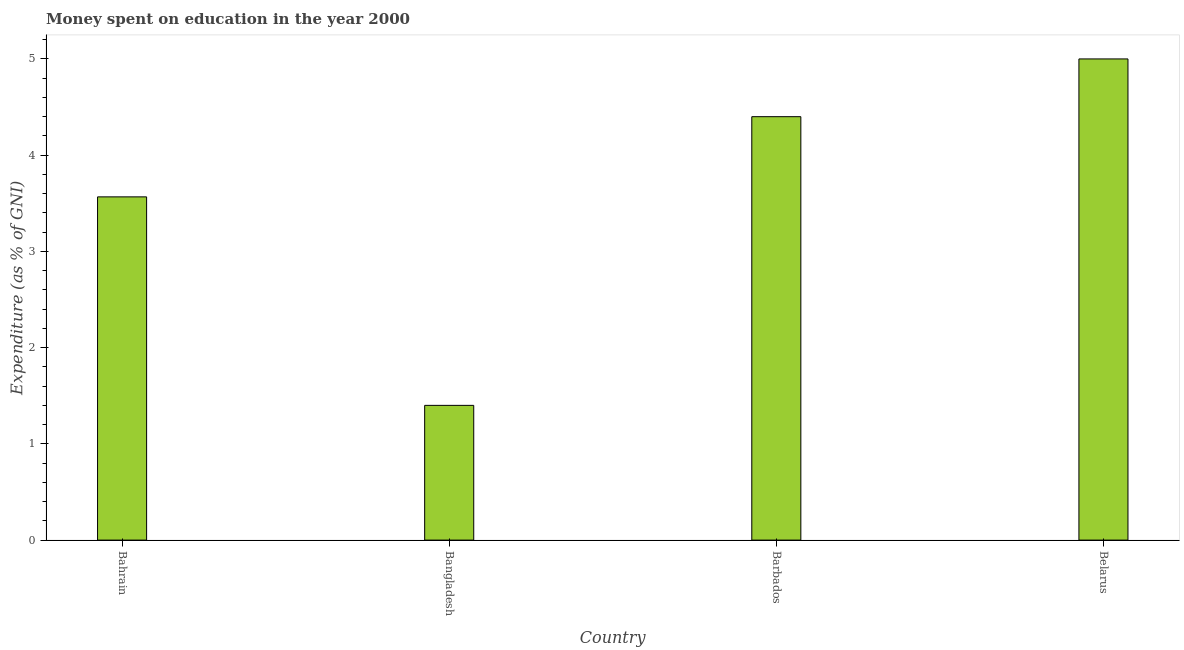Does the graph contain any zero values?
Provide a short and direct response. No. Does the graph contain grids?
Your answer should be very brief. No. What is the title of the graph?
Your answer should be compact. Money spent on education in the year 2000. What is the label or title of the X-axis?
Ensure brevity in your answer.  Country. What is the label or title of the Y-axis?
Your response must be concise. Expenditure (as % of GNI). What is the expenditure on education in Bangladesh?
Make the answer very short. 1.4. In which country was the expenditure on education maximum?
Make the answer very short. Belarus. What is the sum of the expenditure on education?
Your answer should be very brief. 14.37. What is the difference between the expenditure on education in Bahrain and Barbados?
Keep it short and to the point. -0.83. What is the average expenditure on education per country?
Your answer should be compact. 3.59. What is the median expenditure on education?
Your answer should be very brief. 3.98. In how many countries, is the expenditure on education greater than 4.4 %?
Your response must be concise. 1. What is the ratio of the expenditure on education in Bahrain to that in Bangladesh?
Your answer should be very brief. 2.55. Is the expenditure on education in Barbados less than that in Belarus?
Offer a terse response. Yes. How many bars are there?
Keep it short and to the point. 4. Are all the bars in the graph horizontal?
Keep it short and to the point. No. What is the Expenditure (as % of GNI) in Bahrain?
Provide a succinct answer. 3.57. What is the difference between the Expenditure (as % of GNI) in Bahrain and Bangladesh?
Offer a very short reply. 2.17. What is the difference between the Expenditure (as % of GNI) in Bahrain and Barbados?
Provide a succinct answer. -0.83. What is the difference between the Expenditure (as % of GNI) in Bahrain and Belarus?
Give a very brief answer. -1.43. What is the difference between the Expenditure (as % of GNI) in Bangladesh and Barbados?
Offer a terse response. -3. What is the difference between the Expenditure (as % of GNI) in Bangladesh and Belarus?
Offer a terse response. -3.6. What is the difference between the Expenditure (as % of GNI) in Barbados and Belarus?
Make the answer very short. -0.6. What is the ratio of the Expenditure (as % of GNI) in Bahrain to that in Bangladesh?
Provide a short and direct response. 2.55. What is the ratio of the Expenditure (as % of GNI) in Bahrain to that in Barbados?
Make the answer very short. 0.81. What is the ratio of the Expenditure (as % of GNI) in Bahrain to that in Belarus?
Your answer should be very brief. 0.71. What is the ratio of the Expenditure (as % of GNI) in Bangladesh to that in Barbados?
Your answer should be very brief. 0.32. What is the ratio of the Expenditure (as % of GNI) in Bangladesh to that in Belarus?
Offer a very short reply. 0.28. 